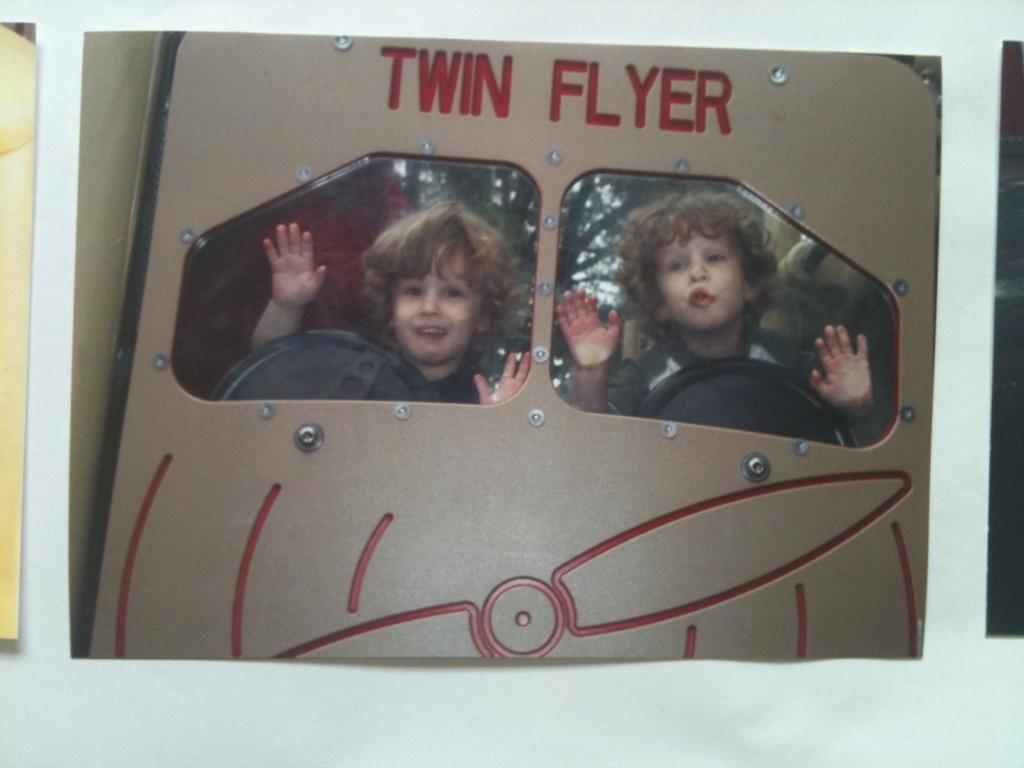What is depicted in the image? There is a picture of two kids in the image. What can be found at the top of the image? There is text written at the top of the image. What color is the background of the image? The background of the image is white. How many people are in the crowd surrounding the tent and volcano in the image? There is no crowd, tent, or volcano present in the image; it only features a picture of two kids and text at the top. 